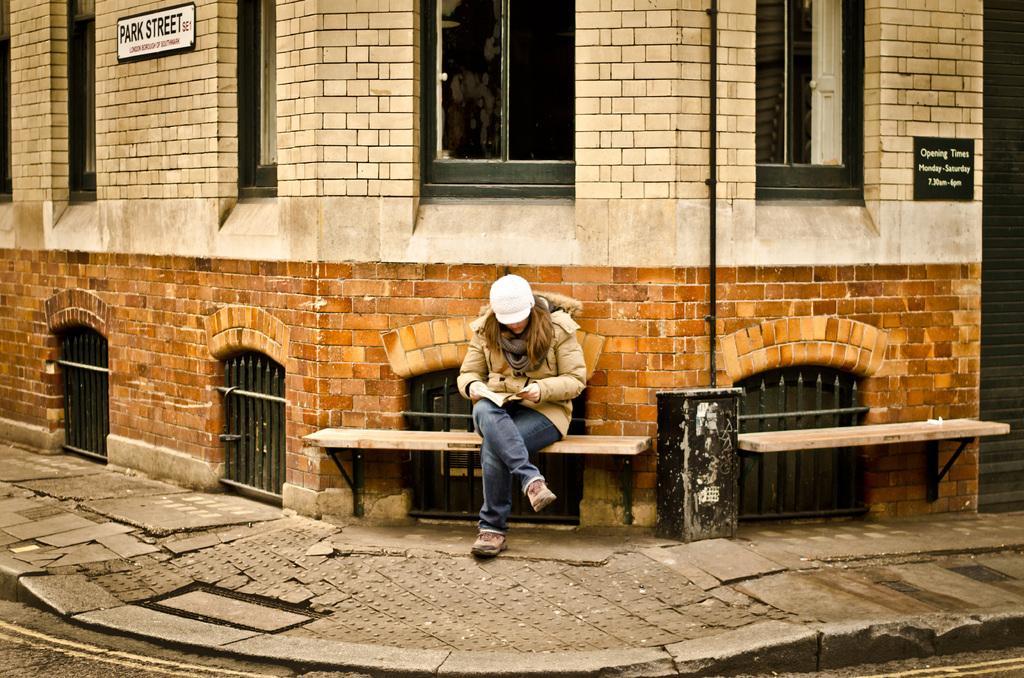In one or two sentences, can you explain what this image depicts? Here we can see a woman is sitting on the bench, and at back here is the wall made of bricks, and here is the window, and here is the building. 